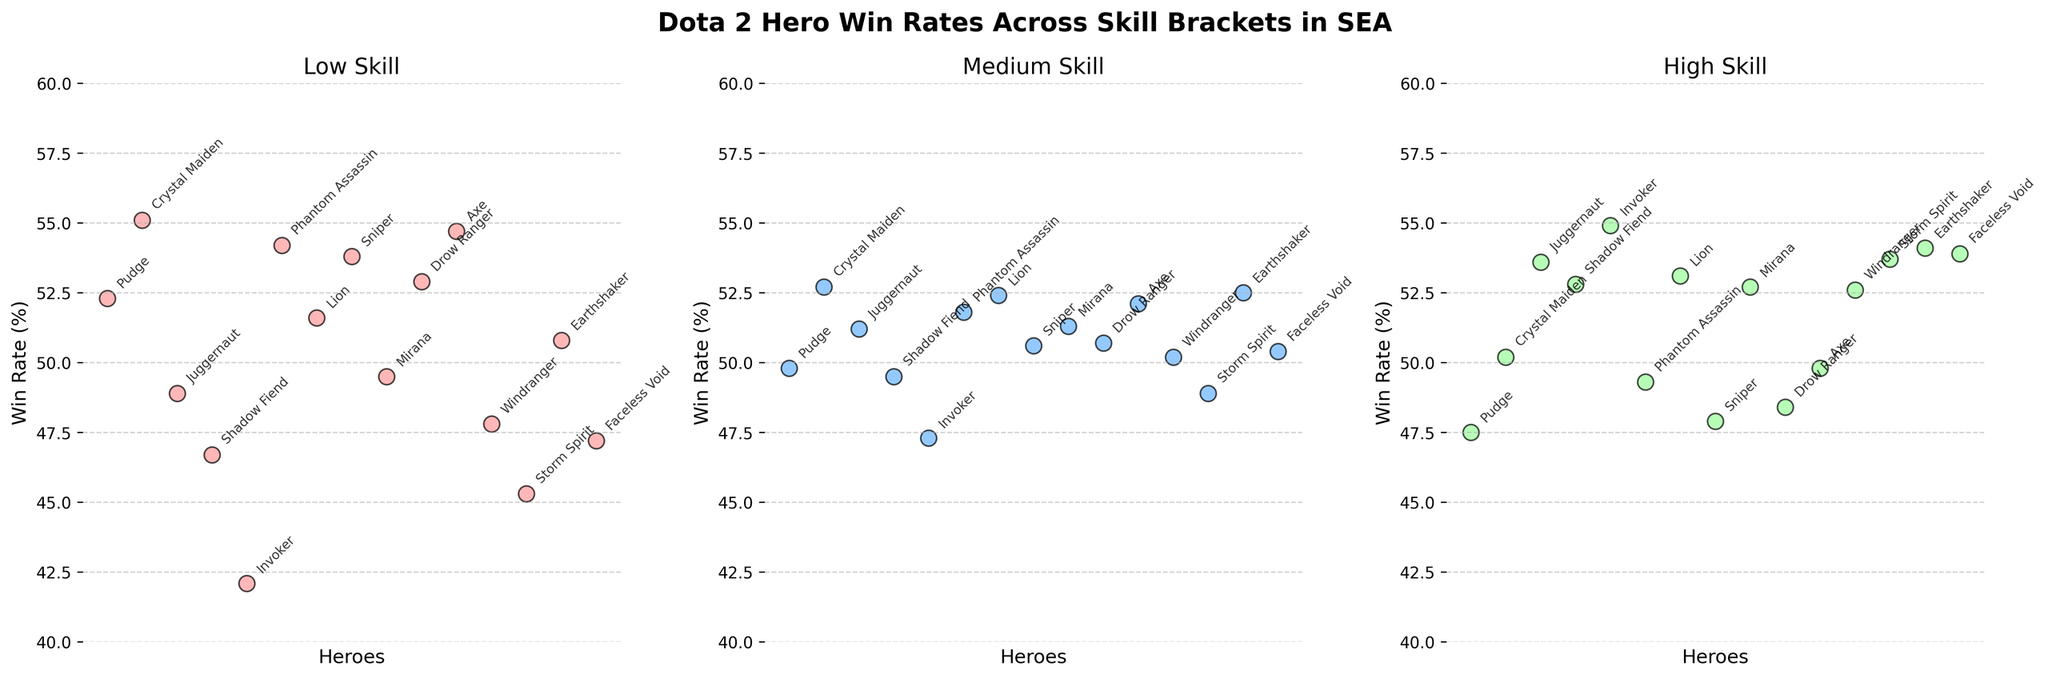what is the title of the figure? The title can be found at the top of the figure and summarizes what the figure represents. Here, it reads "Dota 2 Hero Win Rates Across Skill Brackets in SEA".
Answer: Dota 2 Hero Win Rates Across Skill Brackets in SEA How many heroes have win rates above 50% in the Low Skill bracket? The win rates in the Low Skill bracket are shown in the first subplot. Counting the heroes with win rates above 50% gives us Pudge, Crystal Maiden, Sniper, Phantom Assassin, Axe, and Drow Ranger, for a total of 6 heroes.
Answer: 6 Which hero has the highest win rate in the High Skill bracket? In the third subplot, the win rates for the High Skill bracket are displayed. By comparing the values, Invoker has the highest win rate of 54.9%.
Answer: Invoker What is the difference in win rates between the Low Skill and High Skill brackets for Axe? Axe's win rates are shown as 54.7% in the Low Skill bracket and 49.8% in the High Skill bracket. The difference is calculated as 54.7% - 49.8% = 4.9%.
Answer: 4.9% Which hero shows the largest increase in win rate from Low Skill to High Skill? Calculating the increase in win rates for each hero: Shadow Fiend (6.1%), Invoker (12.8%), Juggernaut (4.7%), etc. Invoker has the largest increase of 12.8%.
Answer: Invoker Which skill bracket shows the most balanced win rates across all heroes? By observing the plots, the Medium Skill bracket shows win rates that are more tightly clustered around the middle compared to the other skill brackets.
Answer: Medium Skill Are there any heroes whose win rate decreases consistently from Low Skill to High Skill? From the plots, Sniper, Pudge, Phantom Assassin, Drow Ranger, Crystal Maiden, and Axe have a consistent decrease in win rates from Low to High Skill brackets.
Answer: Yes What's the average win rate for heroes in the Medium Skill bracket? Sum the win rates from the second subplot: 49.8 + 52.7 + 51.2 + 49.5 + 47.3 + 51.8 + 52.4 + 50.6 + 51.3 + 50.7 + 52.1 + 50.2 + 48.9 + 52.5 + 50.4 = 761.4. There are 15 heroes, so the average is 761.4/15 = 50.76%.
Answer: 50.76% Which hero has the highest win rate in the Medium Skill bracket? Reviewing the second subplot, the highest win rate is Crystal Maiden with 52.7%.
Answer: Crystal Maiden Compare the win rate trend of Juggernaut and Shadow Fiend across the three skill brackets. Juggernaut's win rates increase from 48.9% to 51.2% to 53.6%. Shadow Fiend's win rates increase from 46.7% to 49.5% to 52.8%. Both show an increasing trend, but Juggernaut's increase is more significant.
Answer: Juggernaut increases more 